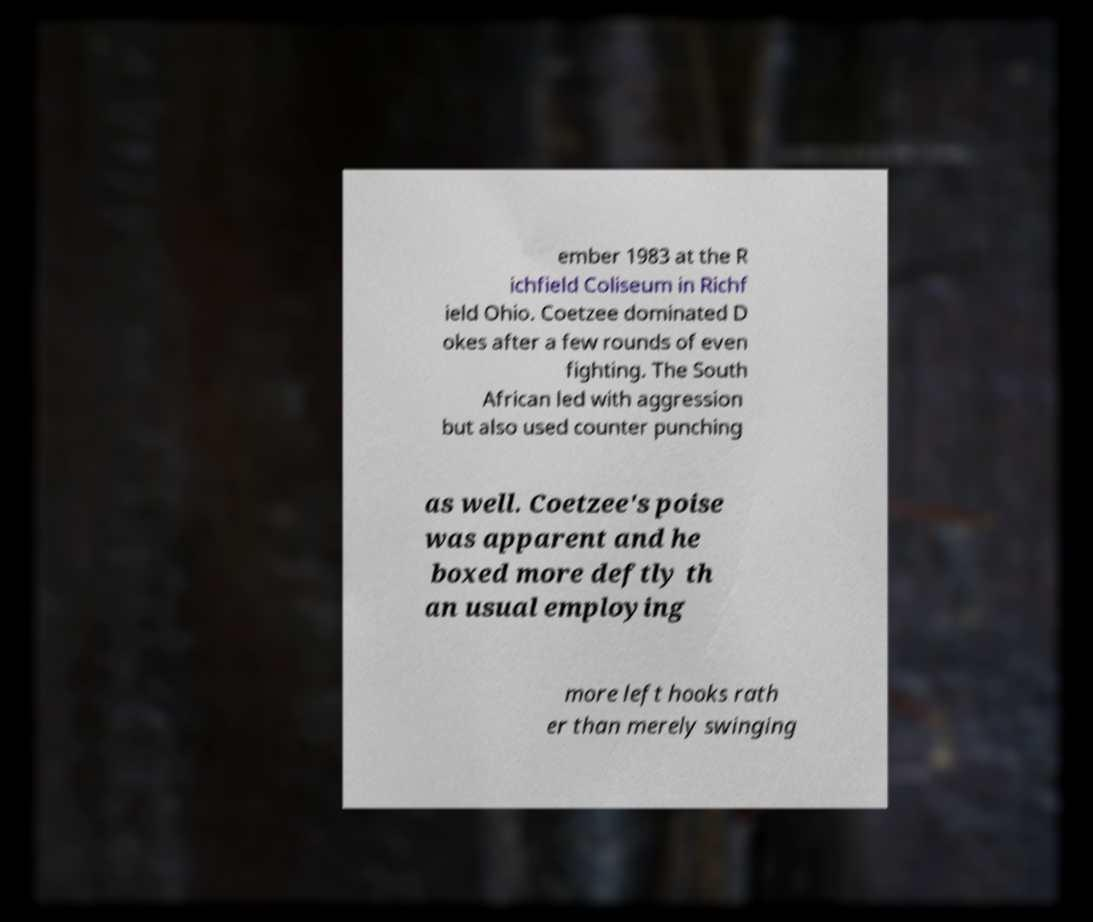For documentation purposes, I need the text within this image transcribed. Could you provide that? ember 1983 at the R ichfield Coliseum in Richf ield Ohio. Coetzee dominated D okes after a few rounds of even fighting. The South African led with aggression but also used counter punching as well. Coetzee's poise was apparent and he boxed more deftly th an usual employing more left hooks rath er than merely swinging 